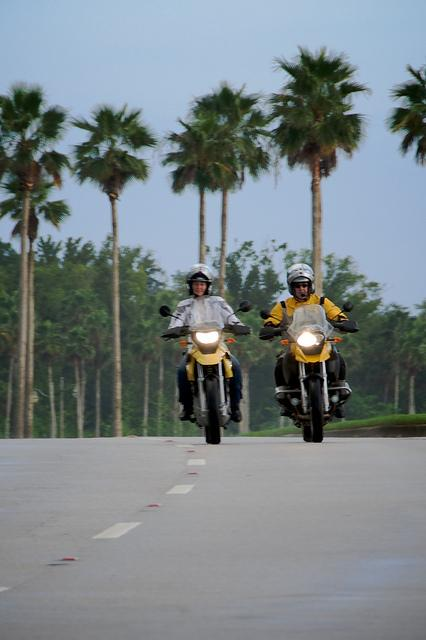What type of vehicle are the men riding? Please explain your reasoning. motorcycle. The men are riding on a motorcycle. 